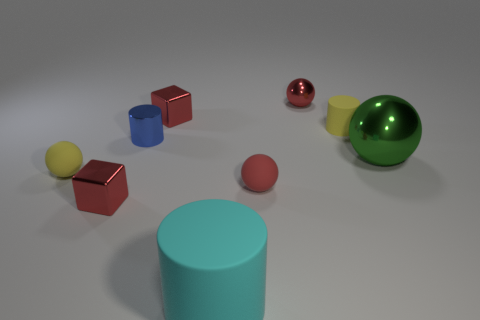Subtract all purple blocks. Subtract all blue balls. How many blocks are left? 2 Subtract all cubes. How many objects are left? 7 Add 5 cubes. How many cubes exist? 7 Subtract 0 yellow cubes. How many objects are left? 9 Subtract all yellow balls. Subtract all cylinders. How many objects are left? 5 Add 5 red metal things. How many red metal things are left? 8 